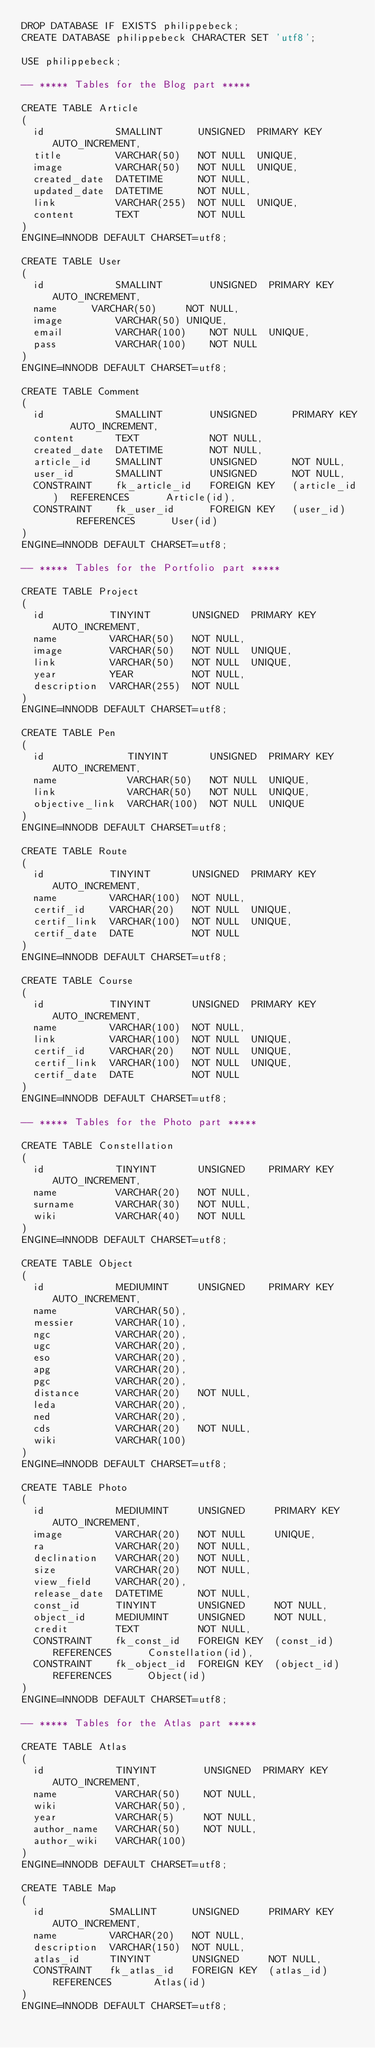Convert code to text. <code><loc_0><loc_0><loc_500><loc_500><_SQL_>DROP DATABASE IF EXISTS philippebeck;
CREATE DATABASE philippebeck CHARACTER SET 'utf8';

USE philippebeck;

-- ***** Tables for the Blog part *****

CREATE TABLE Article
(
  id            SMALLINT      UNSIGNED  PRIMARY KEY AUTO_INCREMENT,
  title         VARCHAR(50)   NOT NULL  UNIQUE,
  image         VARCHAR(50)   NOT NULL  UNIQUE,
  created_date  DATETIME      NOT NULL,
  updated_date  DATETIME      NOT NULL,
  link          VARCHAR(255)  NOT NULL  UNIQUE,
  content       TEXT          NOT NULL
)
ENGINE=INNODB DEFAULT CHARSET=utf8;

CREATE TABLE User
(
  id            SMALLINT      	UNSIGNED  PRIMARY KEY AUTO_INCREMENT,
  name    	VARCHAR(50)   	NOT NULL,
  image         VARCHAR(50)	UNIQUE,
  email         VARCHAR(100)  	NOT NULL  UNIQUE,
  pass          VARCHAR(100)  	NOT NULL
)
ENGINE=INNODB DEFAULT CHARSET=utf8;

CREATE TABLE Comment
(
  id            SMALLINT        UNSIGNED      PRIMARY KEY   AUTO_INCREMENT,
  content       TEXT            NOT NULL,
  created_date  DATETIME        NOT NULL,
  article_id    SMALLINT        UNSIGNED      NOT NULL,
  user_id       SMALLINT        UNSIGNED      NOT NULL,
  CONSTRAINT    fk_article_id   FOREIGN KEY   (article_id)  REFERENCES      Article(id),
  CONSTRAINT    fk_user_id      FOREIGN KEY   (user_id)     REFERENCES      User(id)
)
ENGINE=INNODB DEFAULT CHARSET=utf8;

-- ***** Tables for the Portfolio part *****

CREATE TABLE Project
(
  id           TINYINT       UNSIGNED  PRIMARY KEY   AUTO_INCREMENT,
  name         VARCHAR(50)   NOT NULL,
  image        VARCHAR(50)   NOT NULL  UNIQUE,
  link         VARCHAR(50)   NOT NULL  UNIQUE,
  year         YEAR          NOT NULL,
  description  VARCHAR(255)  NOT NULL
)
ENGINE=INNODB DEFAULT CHARSET=utf8;

CREATE TABLE Pen
(
  id              TINYINT       UNSIGNED  PRIMARY KEY   AUTO_INCREMENT,
  name            VARCHAR(50)   NOT NULL  UNIQUE,
  link            VARCHAR(50)   NOT NULL  UNIQUE,
  objective_link  VARCHAR(100)  NOT NULL  UNIQUE
)
ENGINE=INNODB DEFAULT CHARSET=utf8;

CREATE TABLE Route
(
  id           TINYINT       UNSIGNED  PRIMARY KEY   AUTO_INCREMENT,
  name         VARCHAR(100)  NOT NULL,
  certif_id    VARCHAR(20)   NOT NULL  UNIQUE,
  certif_link  VARCHAR(100)  NOT NULL  UNIQUE,
  certif_date  DATE          NOT NULL
)
ENGINE=INNODB DEFAULT CHARSET=utf8;

CREATE TABLE Course
(
  id           TINYINT       UNSIGNED  PRIMARY KEY   AUTO_INCREMENT,
  name         VARCHAR(100)  NOT NULL,
  link         VARCHAR(100)  NOT NULL  UNIQUE,
  certif_id    VARCHAR(20)   NOT NULL  UNIQUE,
  certif_link  VARCHAR(100)  NOT NULL  UNIQUE,
  certif_date  DATE          NOT NULL
)
ENGINE=INNODB DEFAULT CHARSET=utf8;

-- ***** Tables for the Photo part *****

CREATE TABLE Constellation
(
  id            TINYINT       UNSIGNED    PRIMARY KEY   AUTO_INCREMENT,
  name          VARCHAR(20)   NOT NULL,
  surname       VARCHAR(30)   NOT NULL,
  wiki          VARCHAR(40)   NOT NULL
)
ENGINE=INNODB DEFAULT CHARSET=utf8;

CREATE TABLE Object
(
  id            MEDIUMINT     UNSIGNED    PRIMARY KEY  AUTO_INCREMENT,
  name          VARCHAR(50),
  messier       VARCHAR(10),
  ngc           VARCHAR(20),
  ugc           VARCHAR(20),
  eso           VARCHAR(20),
  apg           VARCHAR(20),
  pgc           VARCHAR(20),
  distance      VARCHAR(20)   NOT NULL,
  leda          VARCHAR(20),
  ned           VARCHAR(20),
  cds           VARCHAR(20)   NOT NULL,
  wiki          VARCHAR(100)
)
ENGINE=INNODB DEFAULT CHARSET=utf8;

CREATE TABLE Photo
(
  id            MEDIUMINT     UNSIGNED     PRIMARY KEY  AUTO_INCREMENT,
  image         VARCHAR(20)   NOT NULL     UNIQUE,
  ra            VARCHAR(20)   NOT NULL,
  declination   VARCHAR(20)   NOT NULL,
  size          VARCHAR(20)   NOT NULL,
  view_field    VARCHAR(20),
  release_date  DATETIME      NOT NULL,
  const_id      TINYINT       UNSIGNED     NOT NULL,
  object_id     MEDIUMINT     UNSIGNED     NOT NULL,
  credit        TEXT          NOT NULL,
  CONSTRAINT    fk_const_id   FOREIGN KEY  (const_id)   REFERENCES      Constellation(id),
  CONSTRAINT    fk_object_id  FOREIGN KEY  (object_id)  REFERENCES      Object(id)
)
ENGINE=INNODB DEFAULT CHARSET=utf8;

-- ***** Tables for the Atlas part *****

CREATE TABLE Atlas
(
  id            TINYINT        UNSIGNED  PRIMARY KEY AUTO_INCREMENT,
  name          VARCHAR(50)    NOT NULL,
  wiki          VARCHAR(50),
  year          VARCHAR(5)     NOT NULL,
  author_name   VARCHAR(50)    NOT NULL,
  author_wiki   VARCHAR(100)
)
ENGINE=INNODB DEFAULT CHARSET=utf8;

CREATE TABLE Map
(
  id           SMALLINT      UNSIGNED     PRIMARY KEY  AUTO_INCREMENT,
  name         VARCHAR(20)   NOT NULL,
  description  VARCHAR(150)  NOT NULL,
  atlas_id     TINYINT       UNSIGNED     NOT NULL,
  CONSTRAINT   fk_atlas_id   FOREIGN KEY  (atlas_id)   REFERENCES       Atlas(id)
)
ENGINE=INNODB DEFAULT CHARSET=utf8;
</code> 